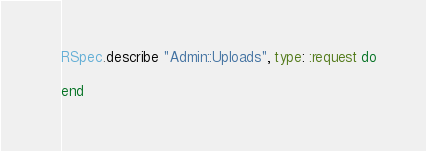Convert code to text. <code><loc_0><loc_0><loc_500><loc_500><_Ruby_>
RSpec.describe "Admin::Uploads", type: :request do

end
</code> 